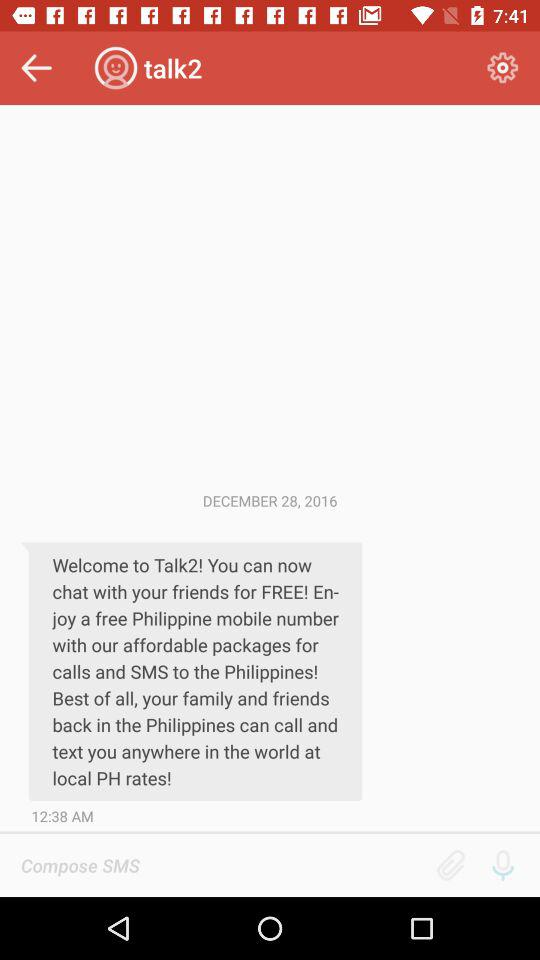On what date was the message delivered? The message was delivered on December 28, 2016. 